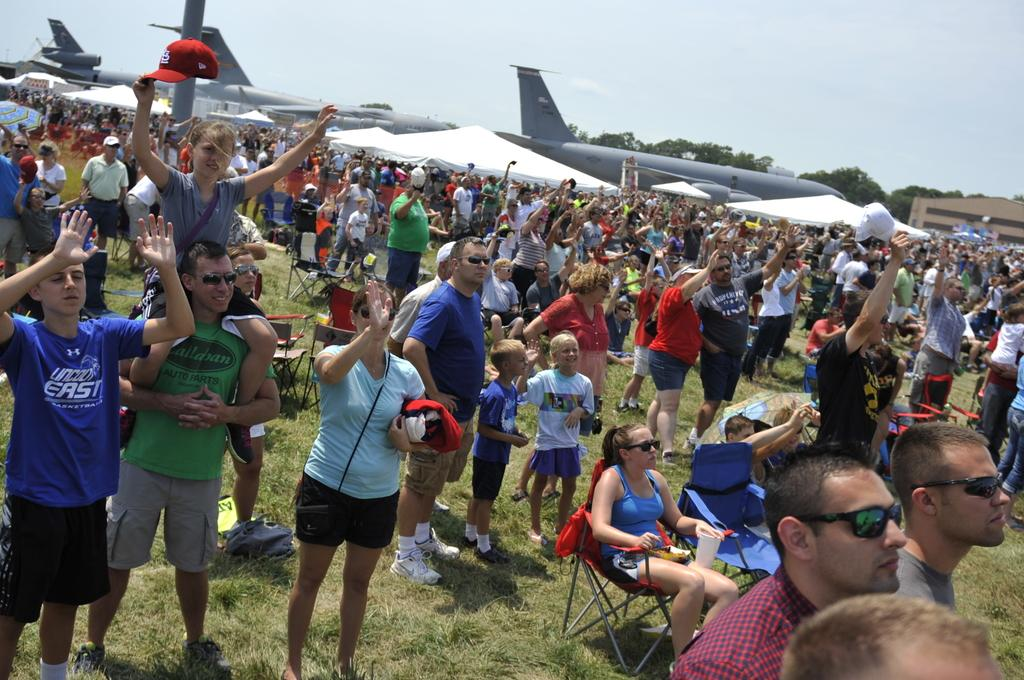What can be seen in the image in terms of people? There are groups of people in the image. What type of ground surface is visible in the image? Grass is present in the image. What type of seating is available in the image? Chairs are visible in the image. What type of protection from the sun is present in the image? Umbrellas are in the image. What type of headwear is present in the image? Caps are present in the image. What type of transportation is visible in the image? Airplanes are visible in the image. What type of structures are present in the image? There are buildings in the image. What type of vegetation is present in the image? Trees are present in the image. What part of the natural environment is visible in the image? The sky is visible in the image. What type of star can be seen in the image? There is no star present in the image. What type of crush is being experienced by the people in the image? There is no indication of any crush being experienced by the people in the image. 